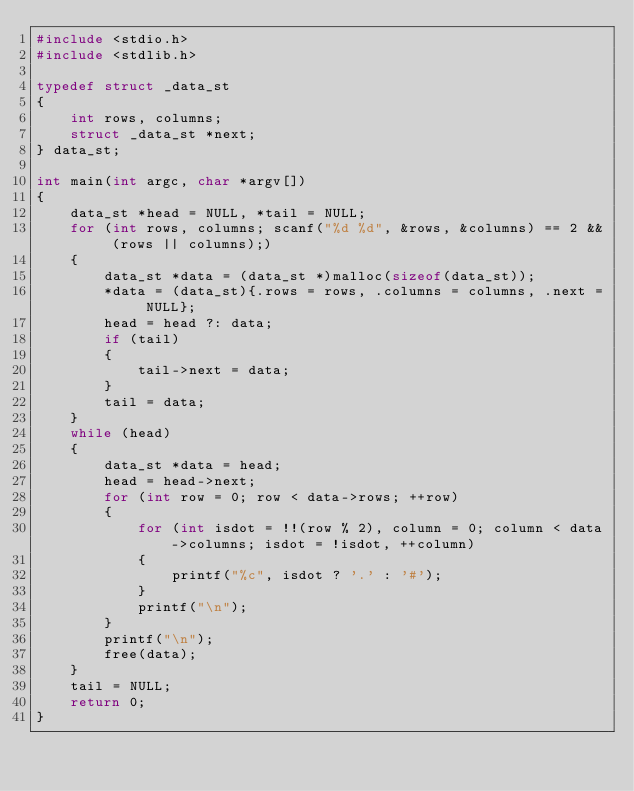Convert code to text. <code><loc_0><loc_0><loc_500><loc_500><_C_>#include <stdio.h>
#include <stdlib.h>

typedef struct _data_st
{
    int rows, columns;
    struct _data_st *next;
} data_st;

int main(int argc, char *argv[])
{
    data_st *head = NULL, *tail = NULL;
    for (int rows, columns; scanf("%d %d", &rows, &columns) == 2 && (rows || columns);)
    {
        data_st *data = (data_st *)malloc(sizeof(data_st));
        *data = (data_st){.rows = rows, .columns = columns, .next = NULL};
        head = head ?: data;
        if (tail)
        {
            tail->next = data;
        }
        tail = data;
    }
    while (head)
    {
        data_st *data = head;
        head = head->next;
        for (int row = 0; row < data->rows; ++row)
        {
            for (int isdot = !!(row % 2), column = 0; column < data->columns; isdot = !isdot, ++column)
            {
                printf("%c", isdot ? '.' : '#');
            }
            printf("\n");
        }
        printf("\n");
        free(data);
    }
    tail = NULL;
    return 0;
}

</code> 